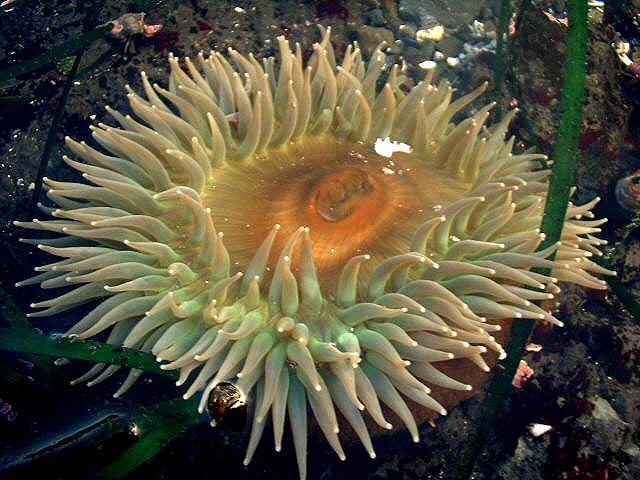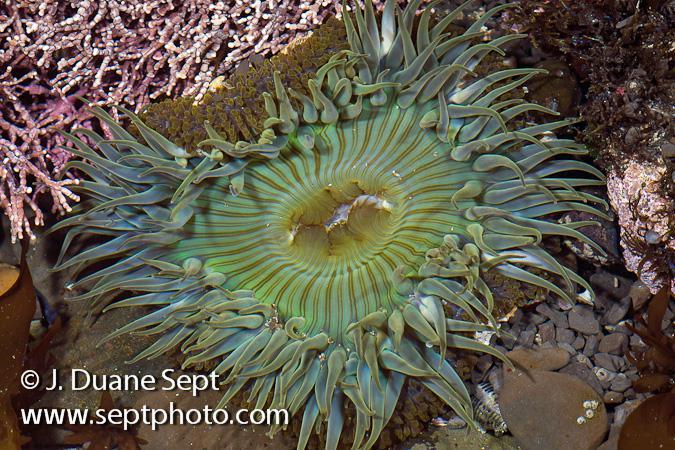The first image is the image on the left, the second image is the image on the right. Examine the images to the left and right. Is the description "There is exactly one sea anemone in the right image." accurate? Answer yes or no. Yes. The first image is the image on the left, the second image is the image on the right. Given the left and right images, does the statement "Each image shows one prominent flower-shaped anemone with tendrils radiating from a flatter center with a hole in it, but the anemone on the right is greenish-blue, and the one on the left is more yellowish." hold true? Answer yes or no. Yes. 